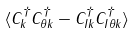Convert formula to latex. <formula><loc_0><loc_0><loc_500><loc_500>\ \langle C _ { k } ^ { \dagger } C _ { \theta k } ^ { \dagger } - C _ { I k } ^ { \dagger } C _ { I \theta k } ^ { \dagger } \rangle</formula> 